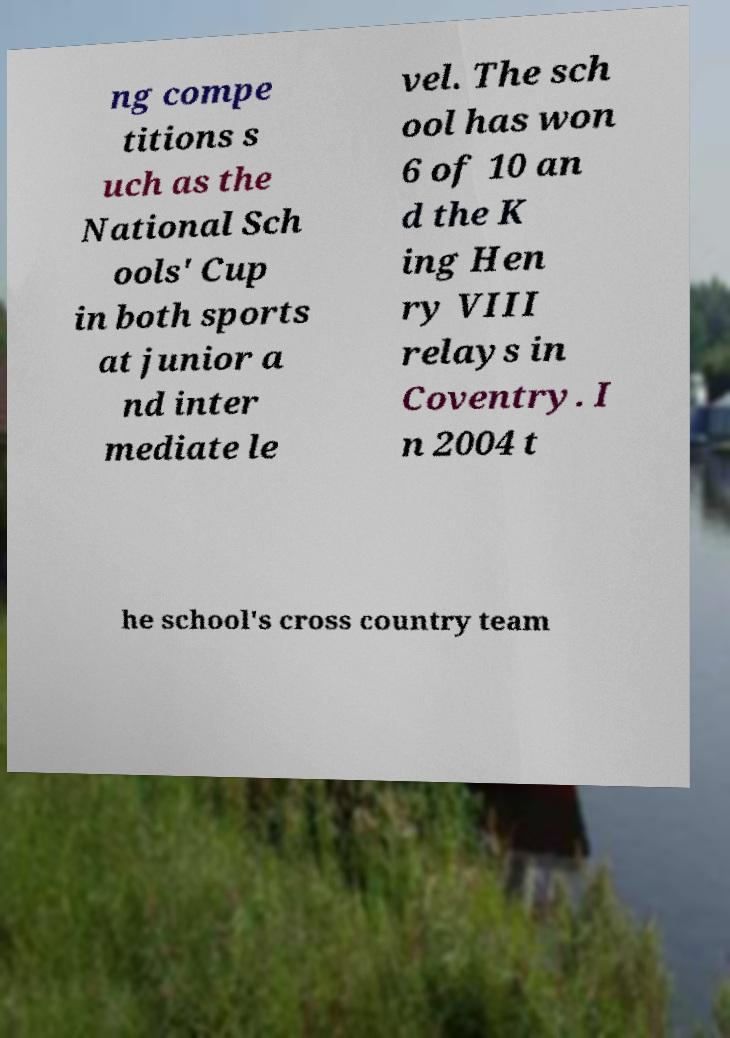Can you accurately transcribe the text from the provided image for me? ng compe titions s uch as the National Sch ools' Cup in both sports at junior a nd inter mediate le vel. The sch ool has won 6 of 10 an d the K ing Hen ry VIII relays in Coventry. I n 2004 t he school's cross country team 